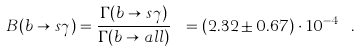<formula> <loc_0><loc_0><loc_500><loc_500>B ( b \to s \gamma ) = \frac { \Gamma ( b \to s \gamma ) } { \Gamma ( b \to a l l ) } \ = ( 2 . 3 2 \pm 0 . 6 7 ) \cdot 1 0 ^ { - 4 } \ .</formula> 